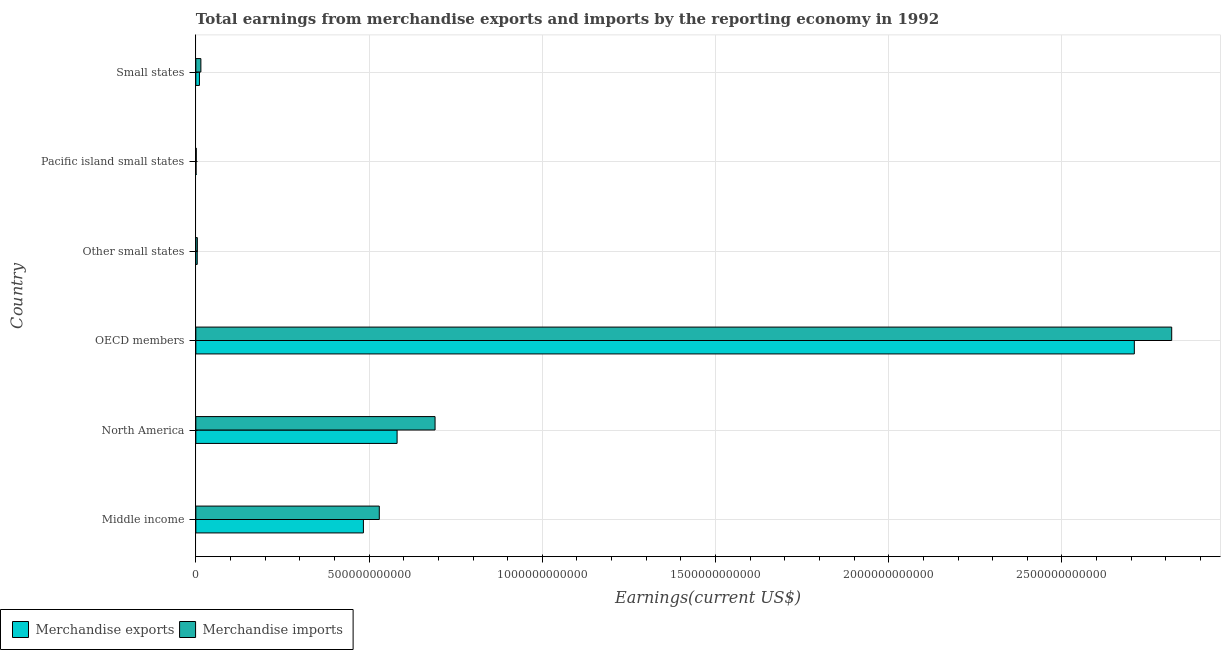Are the number of bars on each tick of the Y-axis equal?
Keep it short and to the point. Yes. How many bars are there on the 4th tick from the top?
Offer a terse response. 2. What is the label of the 4th group of bars from the top?
Provide a short and direct response. OECD members. What is the earnings from merchandise exports in North America?
Your answer should be compact. 5.81e+11. Across all countries, what is the maximum earnings from merchandise imports?
Keep it short and to the point. 2.82e+12. Across all countries, what is the minimum earnings from merchandise imports?
Offer a terse response. 1.21e+09. In which country was the earnings from merchandise imports maximum?
Your response must be concise. OECD members. In which country was the earnings from merchandise imports minimum?
Your answer should be compact. Pacific island small states. What is the total earnings from merchandise imports in the graph?
Give a very brief answer. 4.06e+12. What is the difference between the earnings from merchandise imports in Middle income and that in Pacific island small states?
Offer a very short reply. 5.28e+11. What is the difference between the earnings from merchandise imports in Small states and the earnings from merchandise exports in OECD members?
Give a very brief answer. -2.69e+12. What is the average earnings from merchandise imports per country?
Your answer should be compact. 6.76e+11. What is the difference between the earnings from merchandise imports and earnings from merchandise exports in North America?
Your answer should be compact. 1.10e+11. What is the ratio of the earnings from merchandise exports in OECD members to that in Other small states?
Ensure brevity in your answer.  670.89. What is the difference between the highest and the second highest earnings from merchandise exports?
Provide a succinct answer. 2.13e+12. What is the difference between the highest and the lowest earnings from merchandise exports?
Keep it short and to the point. 2.71e+12. In how many countries, is the earnings from merchandise exports greater than the average earnings from merchandise exports taken over all countries?
Offer a very short reply. 1. What does the 2nd bar from the bottom in Middle income represents?
Offer a very short reply. Merchandise imports. How many bars are there?
Ensure brevity in your answer.  12. Are all the bars in the graph horizontal?
Your answer should be compact. Yes. What is the difference between two consecutive major ticks on the X-axis?
Your answer should be compact. 5.00e+11. Does the graph contain grids?
Your answer should be very brief. Yes. Where does the legend appear in the graph?
Your answer should be compact. Bottom left. How are the legend labels stacked?
Offer a terse response. Horizontal. What is the title of the graph?
Offer a very short reply. Total earnings from merchandise exports and imports by the reporting economy in 1992. Does "RDB concessional" appear as one of the legend labels in the graph?
Your response must be concise. No. What is the label or title of the X-axis?
Offer a very short reply. Earnings(current US$). What is the Earnings(current US$) in Merchandise exports in Middle income?
Provide a succinct answer. 4.84e+11. What is the Earnings(current US$) of Merchandise imports in Middle income?
Ensure brevity in your answer.  5.30e+11. What is the Earnings(current US$) of Merchandise exports in North America?
Provide a succinct answer. 5.81e+11. What is the Earnings(current US$) of Merchandise imports in North America?
Give a very brief answer. 6.91e+11. What is the Earnings(current US$) of Merchandise exports in OECD members?
Ensure brevity in your answer.  2.71e+12. What is the Earnings(current US$) in Merchandise imports in OECD members?
Your answer should be very brief. 2.82e+12. What is the Earnings(current US$) of Merchandise exports in Other small states?
Ensure brevity in your answer.  4.04e+09. What is the Earnings(current US$) of Merchandise imports in Other small states?
Offer a terse response. 4.36e+09. What is the Earnings(current US$) in Merchandise exports in Pacific island small states?
Offer a terse response. 6.15e+08. What is the Earnings(current US$) of Merchandise imports in Pacific island small states?
Give a very brief answer. 1.21e+09. What is the Earnings(current US$) of Merchandise exports in Small states?
Ensure brevity in your answer.  1.04e+1. What is the Earnings(current US$) of Merchandise imports in Small states?
Ensure brevity in your answer.  1.46e+1. Across all countries, what is the maximum Earnings(current US$) in Merchandise exports?
Your answer should be compact. 2.71e+12. Across all countries, what is the maximum Earnings(current US$) of Merchandise imports?
Give a very brief answer. 2.82e+12. Across all countries, what is the minimum Earnings(current US$) of Merchandise exports?
Make the answer very short. 6.15e+08. Across all countries, what is the minimum Earnings(current US$) in Merchandise imports?
Provide a short and direct response. 1.21e+09. What is the total Earnings(current US$) of Merchandise exports in the graph?
Offer a very short reply. 3.79e+12. What is the total Earnings(current US$) in Merchandise imports in the graph?
Make the answer very short. 4.06e+12. What is the difference between the Earnings(current US$) in Merchandise exports in Middle income and that in North America?
Offer a terse response. -9.72e+1. What is the difference between the Earnings(current US$) of Merchandise imports in Middle income and that in North America?
Ensure brevity in your answer.  -1.61e+11. What is the difference between the Earnings(current US$) of Merchandise exports in Middle income and that in OECD members?
Make the answer very short. -2.23e+12. What is the difference between the Earnings(current US$) in Merchandise imports in Middle income and that in OECD members?
Offer a terse response. -2.29e+12. What is the difference between the Earnings(current US$) of Merchandise exports in Middle income and that in Other small states?
Ensure brevity in your answer.  4.80e+11. What is the difference between the Earnings(current US$) in Merchandise imports in Middle income and that in Other small states?
Give a very brief answer. 5.25e+11. What is the difference between the Earnings(current US$) in Merchandise exports in Middle income and that in Pacific island small states?
Offer a very short reply. 4.83e+11. What is the difference between the Earnings(current US$) in Merchandise imports in Middle income and that in Pacific island small states?
Your answer should be very brief. 5.28e+11. What is the difference between the Earnings(current US$) in Merchandise exports in Middle income and that in Small states?
Keep it short and to the point. 4.73e+11. What is the difference between the Earnings(current US$) in Merchandise imports in Middle income and that in Small states?
Make the answer very short. 5.15e+11. What is the difference between the Earnings(current US$) of Merchandise exports in North America and that in OECD members?
Provide a short and direct response. -2.13e+12. What is the difference between the Earnings(current US$) of Merchandise imports in North America and that in OECD members?
Ensure brevity in your answer.  -2.13e+12. What is the difference between the Earnings(current US$) in Merchandise exports in North America and that in Other small states?
Make the answer very short. 5.77e+11. What is the difference between the Earnings(current US$) in Merchandise imports in North America and that in Other small states?
Provide a short and direct response. 6.86e+11. What is the difference between the Earnings(current US$) of Merchandise exports in North America and that in Pacific island small states?
Make the answer very short. 5.80e+11. What is the difference between the Earnings(current US$) in Merchandise imports in North America and that in Pacific island small states?
Provide a short and direct response. 6.89e+11. What is the difference between the Earnings(current US$) of Merchandise exports in North America and that in Small states?
Offer a very short reply. 5.71e+11. What is the difference between the Earnings(current US$) in Merchandise imports in North America and that in Small states?
Ensure brevity in your answer.  6.76e+11. What is the difference between the Earnings(current US$) in Merchandise exports in OECD members and that in Other small states?
Offer a very short reply. 2.70e+12. What is the difference between the Earnings(current US$) in Merchandise imports in OECD members and that in Other small states?
Offer a very short reply. 2.81e+12. What is the difference between the Earnings(current US$) in Merchandise exports in OECD members and that in Pacific island small states?
Your answer should be very brief. 2.71e+12. What is the difference between the Earnings(current US$) in Merchandise imports in OECD members and that in Pacific island small states?
Keep it short and to the point. 2.82e+12. What is the difference between the Earnings(current US$) in Merchandise exports in OECD members and that in Small states?
Ensure brevity in your answer.  2.70e+12. What is the difference between the Earnings(current US$) in Merchandise imports in OECD members and that in Small states?
Offer a very short reply. 2.80e+12. What is the difference between the Earnings(current US$) in Merchandise exports in Other small states and that in Pacific island small states?
Make the answer very short. 3.42e+09. What is the difference between the Earnings(current US$) of Merchandise imports in Other small states and that in Pacific island small states?
Your response must be concise. 3.14e+09. What is the difference between the Earnings(current US$) of Merchandise exports in Other small states and that in Small states?
Your answer should be compact. -6.31e+09. What is the difference between the Earnings(current US$) of Merchandise imports in Other small states and that in Small states?
Provide a succinct answer. -1.02e+1. What is the difference between the Earnings(current US$) in Merchandise exports in Pacific island small states and that in Small states?
Your answer should be very brief. -9.74e+09. What is the difference between the Earnings(current US$) of Merchandise imports in Pacific island small states and that in Small states?
Your answer should be compact. -1.33e+1. What is the difference between the Earnings(current US$) in Merchandise exports in Middle income and the Earnings(current US$) in Merchandise imports in North America?
Your response must be concise. -2.07e+11. What is the difference between the Earnings(current US$) in Merchandise exports in Middle income and the Earnings(current US$) in Merchandise imports in OECD members?
Your answer should be very brief. -2.33e+12. What is the difference between the Earnings(current US$) in Merchandise exports in Middle income and the Earnings(current US$) in Merchandise imports in Other small states?
Make the answer very short. 4.79e+11. What is the difference between the Earnings(current US$) in Merchandise exports in Middle income and the Earnings(current US$) in Merchandise imports in Pacific island small states?
Offer a very short reply. 4.82e+11. What is the difference between the Earnings(current US$) of Merchandise exports in Middle income and the Earnings(current US$) of Merchandise imports in Small states?
Offer a very short reply. 4.69e+11. What is the difference between the Earnings(current US$) in Merchandise exports in North America and the Earnings(current US$) in Merchandise imports in OECD members?
Provide a succinct answer. -2.24e+12. What is the difference between the Earnings(current US$) in Merchandise exports in North America and the Earnings(current US$) in Merchandise imports in Other small states?
Keep it short and to the point. 5.77e+11. What is the difference between the Earnings(current US$) in Merchandise exports in North America and the Earnings(current US$) in Merchandise imports in Pacific island small states?
Ensure brevity in your answer.  5.80e+11. What is the difference between the Earnings(current US$) in Merchandise exports in North America and the Earnings(current US$) in Merchandise imports in Small states?
Offer a terse response. 5.66e+11. What is the difference between the Earnings(current US$) of Merchandise exports in OECD members and the Earnings(current US$) of Merchandise imports in Other small states?
Keep it short and to the point. 2.70e+12. What is the difference between the Earnings(current US$) in Merchandise exports in OECD members and the Earnings(current US$) in Merchandise imports in Pacific island small states?
Provide a short and direct response. 2.71e+12. What is the difference between the Earnings(current US$) in Merchandise exports in OECD members and the Earnings(current US$) in Merchandise imports in Small states?
Offer a very short reply. 2.69e+12. What is the difference between the Earnings(current US$) in Merchandise exports in Other small states and the Earnings(current US$) in Merchandise imports in Pacific island small states?
Provide a short and direct response. 2.82e+09. What is the difference between the Earnings(current US$) in Merchandise exports in Other small states and the Earnings(current US$) in Merchandise imports in Small states?
Your response must be concise. -1.05e+1. What is the difference between the Earnings(current US$) of Merchandise exports in Pacific island small states and the Earnings(current US$) of Merchandise imports in Small states?
Offer a terse response. -1.39e+1. What is the average Earnings(current US$) of Merchandise exports per country?
Make the answer very short. 6.31e+11. What is the average Earnings(current US$) of Merchandise imports per country?
Make the answer very short. 6.76e+11. What is the difference between the Earnings(current US$) in Merchandise exports and Earnings(current US$) in Merchandise imports in Middle income?
Your answer should be compact. -4.59e+1. What is the difference between the Earnings(current US$) in Merchandise exports and Earnings(current US$) in Merchandise imports in North America?
Your answer should be compact. -1.10e+11. What is the difference between the Earnings(current US$) in Merchandise exports and Earnings(current US$) in Merchandise imports in OECD members?
Your answer should be very brief. -1.08e+11. What is the difference between the Earnings(current US$) of Merchandise exports and Earnings(current US$) of Merchandise imports in Other small states?
Keep it short and to the point. -3.17e+08. What is the difference between the Earnings(current US$) in Merchandise exports and Earnings(current US$) in Merchandise imports in Pacific island small states?
Your answer should be very brief. -5.98e+08. What is the difference between the Earnings(current US$) of Merchandise exports and Earnings(current US$) of Merchandise imports in Small states?
Your response must be concise. -4.20e+09. What is the ratio of the Earnings(current US$) of Merchandise exports in Middle income to that in North America?
Your answer should be compact. 0.83. What is the ratio of the Earnings(current US$) of Merchandise imports in Middle income to that in North America?
Provide a short and direct response. 0.77. What is the ratio of the Earnings(current US$) of Merchandise exports in Middle income to that in OECD members?
Your answer should be compact. 0.18. What is the ratio of the Earnings(current US$) of Merchandise imports in Middle income to that in OECD members?
Offer a very short reply. 0.19. What is the ratio of the Earnings(current US$) of Merchandise exports in Middle income to that in Other small states?
Your answer should be compact. 119.79. What is the ratio of the Earnings(current US$) in Merchandise imports in Middle income to that in Other small states?
Provide a succinct answer. 121.6. What is the ratio of the Earnings(current US$) in Merchandise exports in Middle income to that in Pacific island small states?
Offer a very short reply. 786.27. What is the ratio of the Earnings(current US$) of Merchandise imports in Middle income to that in Pacific island small states?
Give a very brief answer. 436.44. What is the ratio of the Earnings(current US$) of Merchandise exports in Middle income to that in Small states?
Your response must be concise. 46.73. What is the ratio of the Earnings(current US$) in Merchandise imports in Middle income to that in Small states?
Ensure brevity in your answer.  36.4. What is the ratio of the Earnings(current US$) in Merchandise exports in North America to that in OECD members?
Your answer should be compact. 0.21. What is the ratio of the Earnings(current US$) in Merchandise imports in North America to that in OECD members?
Your answer should be compact. 0.25. What is the ratio of the Earnings(current US$) in Merchandise exports in North America to that in Other small states?
Offer a very short reply. 143.88. What is the ratio of the Earnings(current US$) in Merchandise imports in North America to that in Other small states?
Offer a very short reply. 158.55. What is the ratio of the Earnings(current US$) in Merchandise exports in North America to that in Pacific island small states?
Your answer should be very brief. 944.35. What is the ratio of the Earnings(current US$) of Merchandise imports in North America to that in Pacific island small states?
Ensure brevity in your answer.  569.07. What is the ratio of the Earnings(current US$) of Merchandise exports in North America to that in Small states?
Provide a short and direct response. 56.12. What is the ratio of the Earnings(current US$) in Merchandise imports in North America to that in Small states?
Your response must be concise. 47.46. What is the ratio of the Earnings(current US$) in Merchandise exports in OECD members to that in Other small states?
Ensure brevity in your answer.  670.89. What is the ratio of the Earnings(current US$) in Merchandise imports in OECD members to that in Other small states?
Offer a very short reply. 646.75. What is the ratio of the Earnings(current US$) in Merchandise exports in OECD members to that in Pacific island small states?
Your answer should be compact. 4403.48. What is the ratio of the Earnings(current US$) in Merchandise imports in OECD members to that in Pacific island small states?
Provide a succinct answer. 2321.34. What is the ratio of the Earnings(current US$) in Merchandise exports in OECD members to that in Small states?
Provide a short and direct response. 261.7. What is the ratio of the Earnings(current US$) in Merchandise imports in OECD members to that in Small states?
Provide a succinct answer. 193.59. What is the ratio of the Earnings(current US$) in Merchandise exports in Other small states to that in Pacific island small states?
Provide a succinct answer. 6.56. What is the ratio of the Earnings(current US$) of Merchandise imports in Other small states to that in Pacific island small states?
Offer a very short reply. 3.59. What is the ratio of the Earnings(current US$) in Merchandise exports in Other small states to that in Small states?
Ensure brevity in your answer.  0.39. What is the ratio of the Earnings(current US$) in Merchandise imports in Other small states to that in Small states?
Your answer should be very brief. 0.3. What is the ratio of the Earnings(current US$) in Merchandise exports in Pacific island small states to that in Small states?
Your answer should be very brief. 0.06. What is the ratio of the Earnings(current US$) in Merchandise imports in Pacific island small states to that in Small states?
Provide a succinct answer. 0.08. What is the difference between the highest and the second highest Earnings(current US$) in Merchandise exports?
Keep it short and to the point. 2.13e+12. What is the difference between the highest and the second highest Earnings(current US$) in Merchandise imports?
Keep it short and to the point. 2.13e+12. What is the difference between the highest and the lowest Earnings(current US$) of Merchandise exports?
Provide a short and direct response. 2.71e+12. What is the difference between the highest and the lowest Earnings(current US$) of Merchandise imports?
Ensure brevity in your answer.  2.82e+12. 